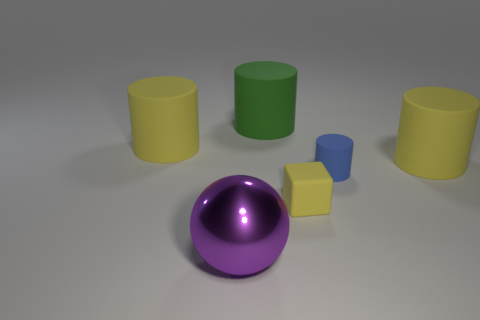What number of other things are there of the same color as the small rubber cylinder?
Your response must be concise. 0. Is the small yellow cube that is behind the large ball made of the same material as the purple sphere?
Your answer should be very brief. No. Is the number of big rubber objects left of the cube less than the number of matte objects that are to the right of the large green rubber cylinder?
Your answer should be very brief. Yes. What number of other things are there of the same material as the green object
Your answer should be very brief. 4. What material is the purple thing that is the same size as the green rubber cylinder?
Ensure brevity in your answer.  Metal. Is the number of large metal balls behind the ball less than the number of small gray metallic objects?
Offer a terse response. No. There is a yellow thing right of the yellow cube in front of the cylinder on the left side of the purple shiny sphere; what shape is it?
Your answer should be compact. Cylinder. What size is the yellow rubber thing in front of the small blue object?
Provide a short and direct response. Small. The green matte thing that is the same size as the shiny ball is what shape?
Give a very brief answer. Cylinder. What number of objects are either cyan metal spheres or large cylinders that are to the left of the small cube?
Ensure brevity in your answer.  2. 